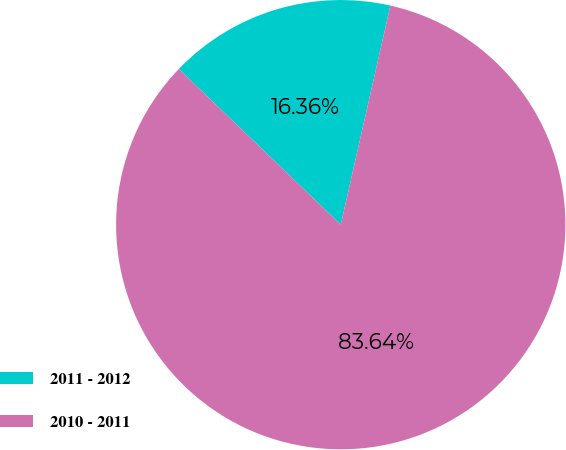<chart> <loc_0><loc_0><loc_500><loc_500><pie_chart><fcel>2011 - 2012<fcel>2010 - 2011<nl><fcel>16.36%<fcel>83.64%<nl></chart> 